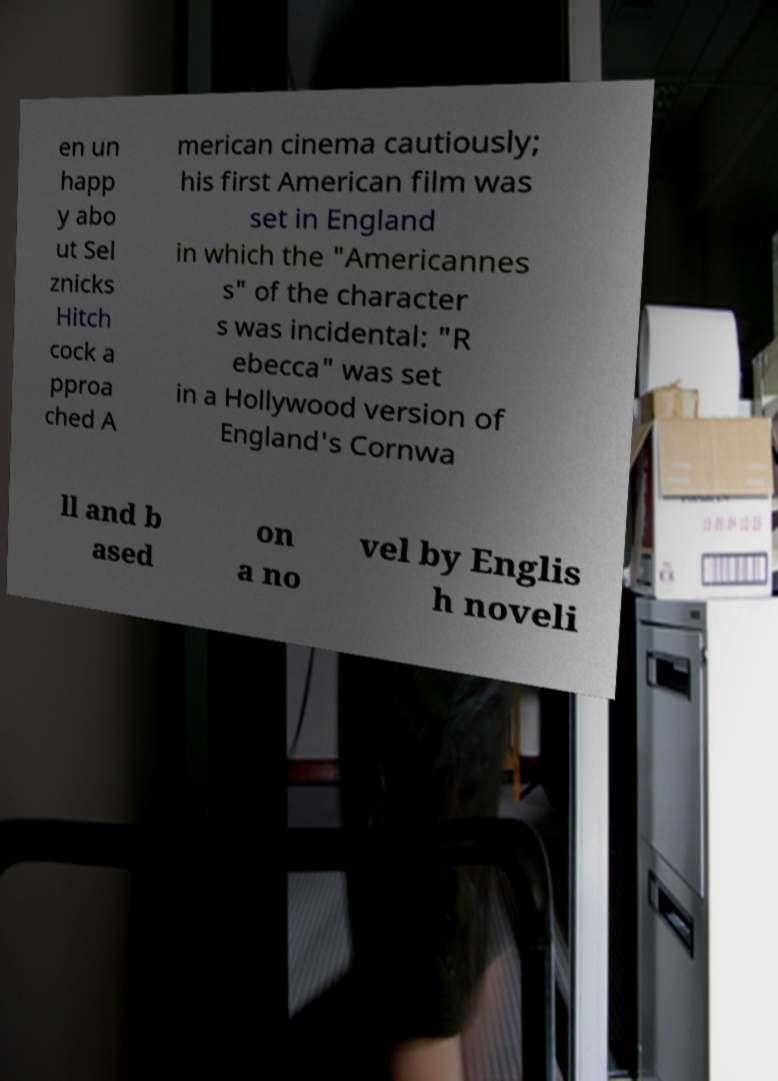There's text embedded in this image that I need extracted. Can you transcribe it verbatim? en un happ y abo ut Sel znicks Hitch cock a pproa ched A merican cinema cautiously; his first American film was set in England in which the "Americannes s" of the character s was incidental: "R ebecca" was set in a Hollywood version of England's Cornwa ll and b ased on a no vel by Englis h noveli 